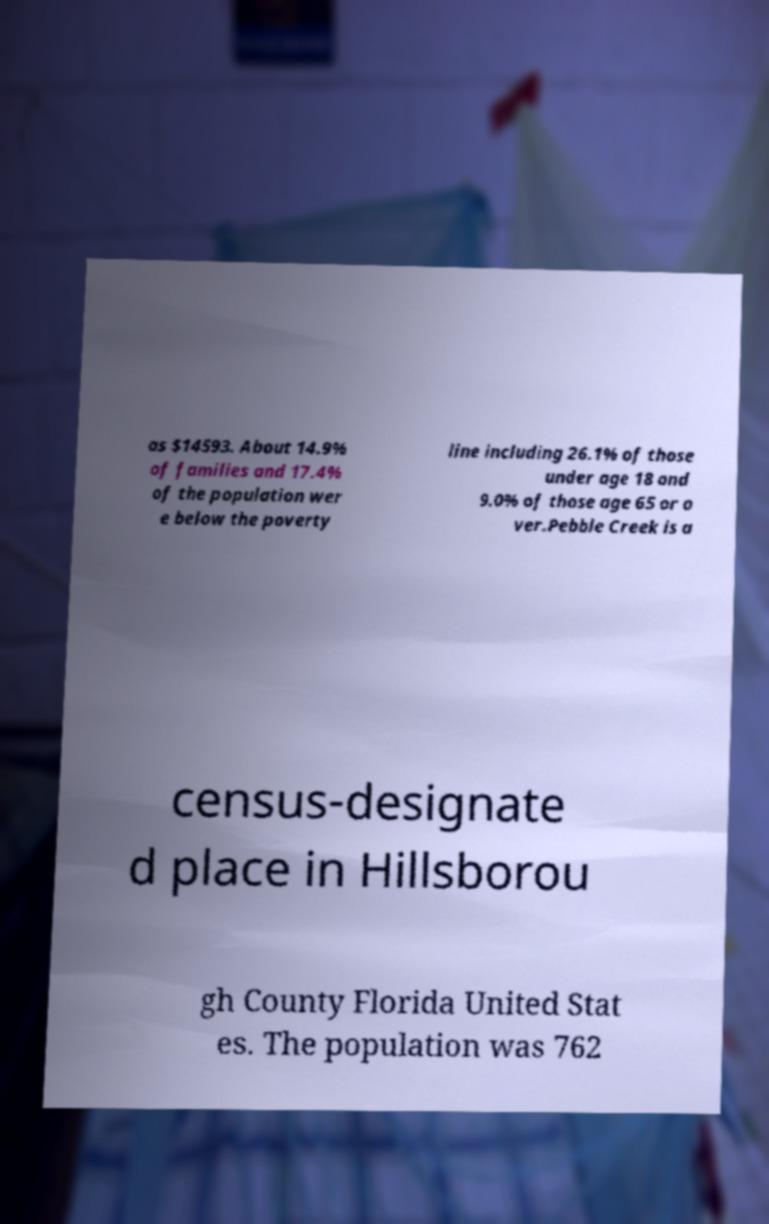Please read and relay the text visible in this image. What does it say? as $14593. About 14.9% of families and 17.4% of the population wer e below the poverty line including 26.1% of those under age 18 and 9.0% of those age 65 or o ver.Pebble Creek is a census-designate d place in Hillsborou gh County Florida United Stat es. The population was 762 